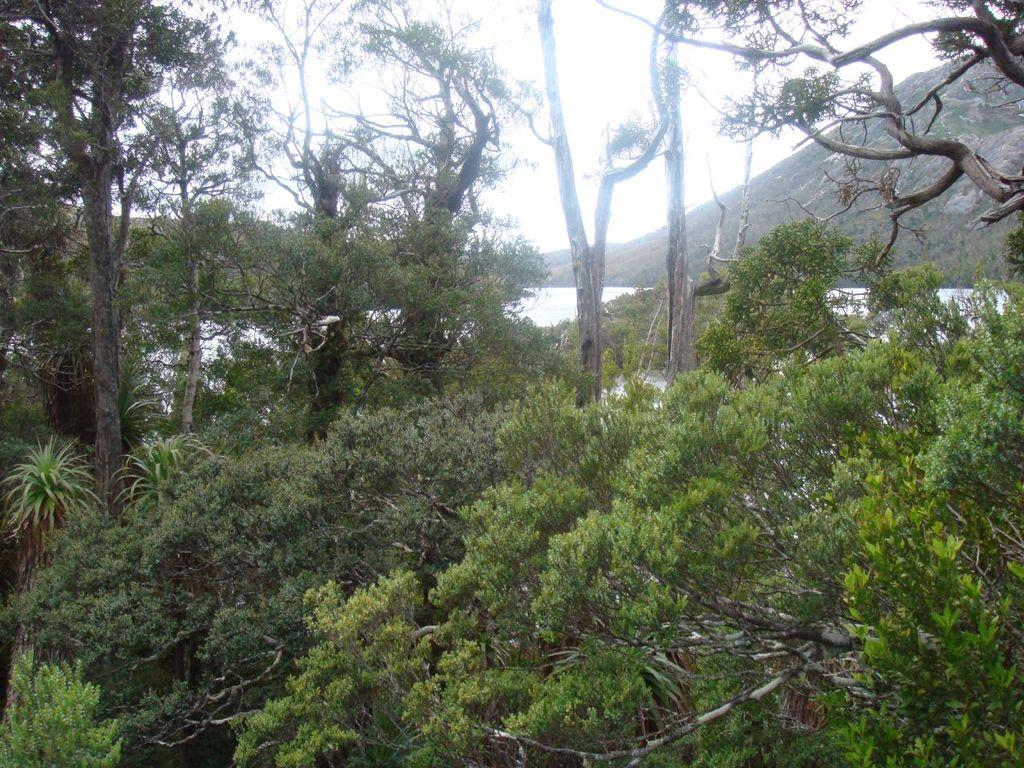What type of vegetation can be seen in the image? There are trees in the image. What geographical features are present in the image? There are hills in the image. What natural element is visible in the image? There is water visible in the image. What letter can be seen floating on the water in the image? There is no letter visible in the image; only trees, hills, and water are present. What type of smell can be detected from the image? The image is visual, so it does not convey any smells. 